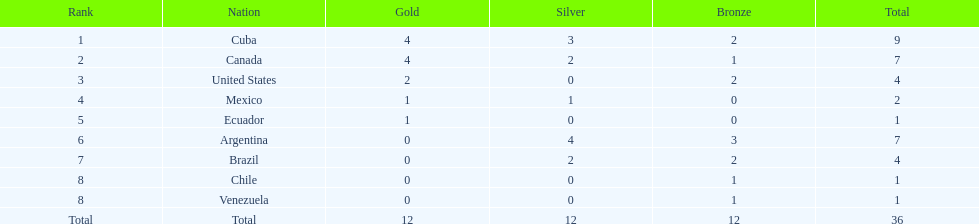What was the overall number of medals combined? 36. Give me the full table as a dictionary. {'header': ['Rank', 'Nation', 'Gold', 'Silver', 'Bronze', 'Total'], 'rows': [['1', 'Cuba', '4', '3', '2', '9'], ['2', 'Canada', '4', '2', '1', '7'], ['3', 'United States', '2', '0', '2', '4'], ['4', 'Mexico', '1', '1', '0', '2'], ['5', 'Ecuador', '1', '0', '0', '1'], ['6', 'Argentina', '0', '4', '3', '7'], ['7', 'Brazil', '0', '2', '2', '4'], ['8', 'Chile', '0', '0', '1', '1'], ['8', 'Venezuela', '0', '0', '1', '1'], ['Total', 'Total', '12', '12', '12', '36']]} 